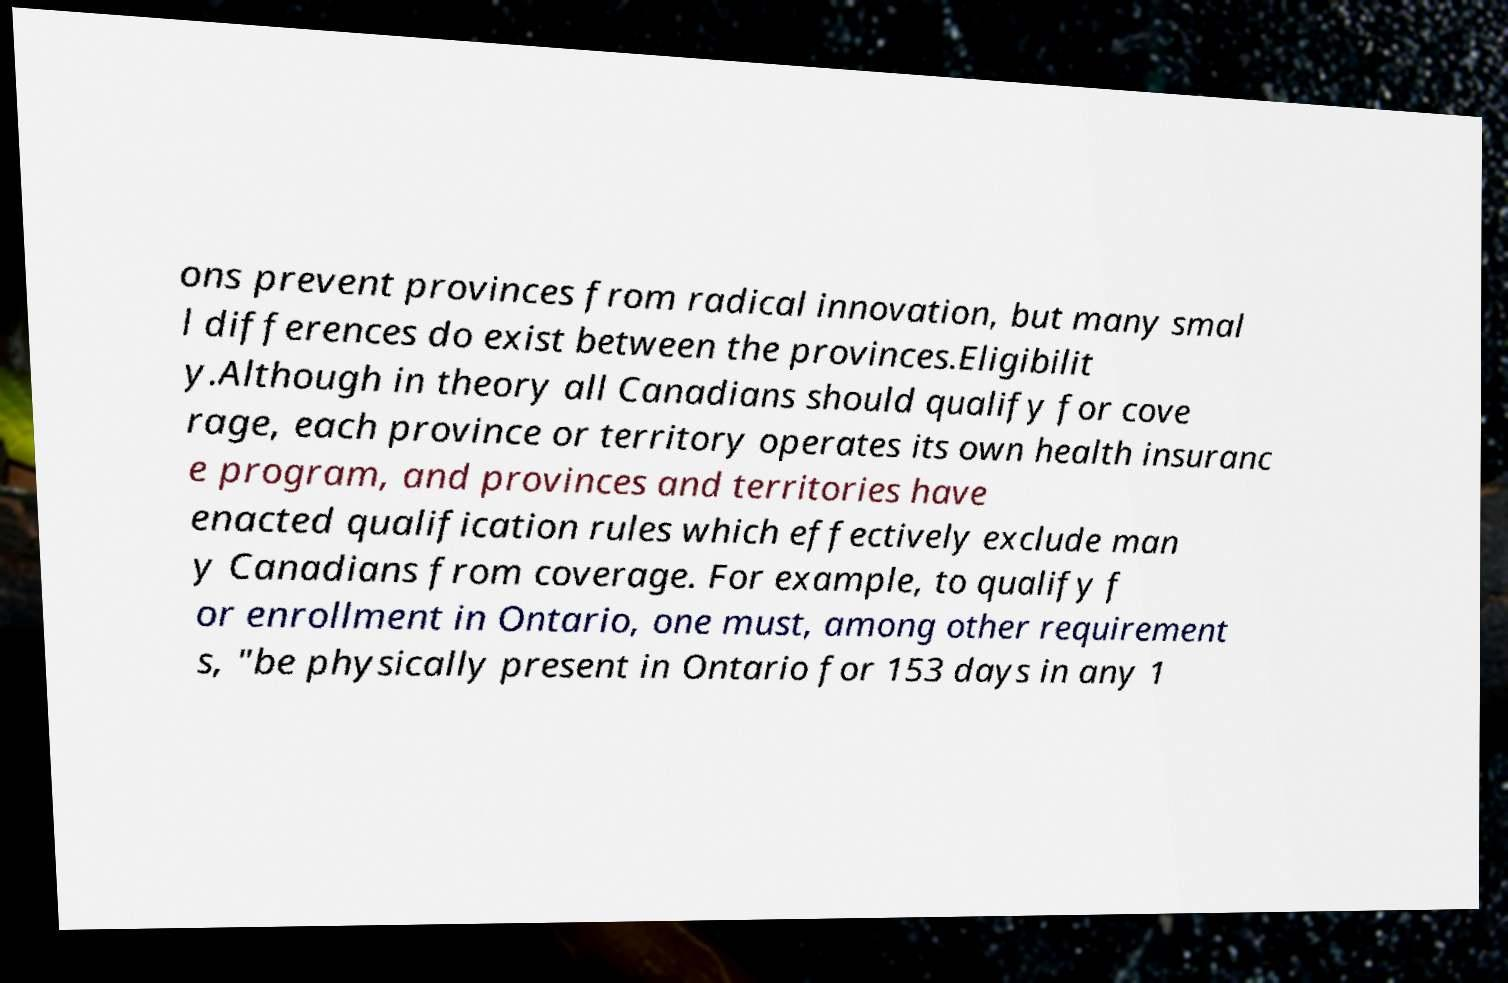Please identify and transcribe the text found in this image. ons prevent provinces from radical innovation, but many smal l differences do exist between the provinces.Eligibilit y.Although in theory all Canadians should qualify for cove rage, each province or territory operates its own health insuranc e program, and provinces and territories have enacted qualification rules which effectively exclude man y Canadians from coverage. For example, to qualify f or enrollment in Ontario, one must, among other requirement s, "be physically present in Ontario for 153 days in any 1 